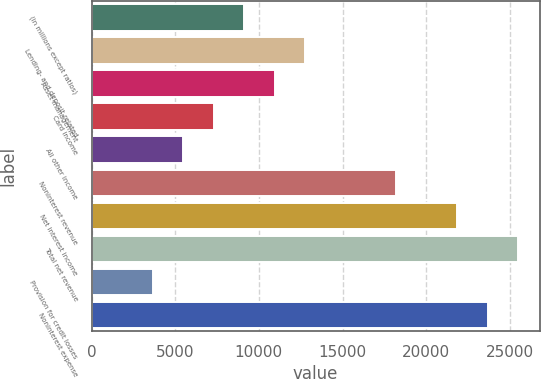Convert chart. <chart><loc_0><loc_0><loc_500><loc_500><bar_chart><fcel>(in millions except ratios)<fcel>Lending- and deposit-related<fcel>Asset management<fcel>Card income<fcel>All other income<fcel>Noninterest revenue<fcel>Net interest income<fcel>Total net revenue<fcel>Provision for credit losses<fcel>Noninterest expense<nl><fcel>9128.5<fcel>12767.5<fcel>10948<fcel>7309<fcel>5489.5<fcel>18226<fcel>21865<fcel>25504<fcel>3670<fcel>23684.5<nl></chart> 